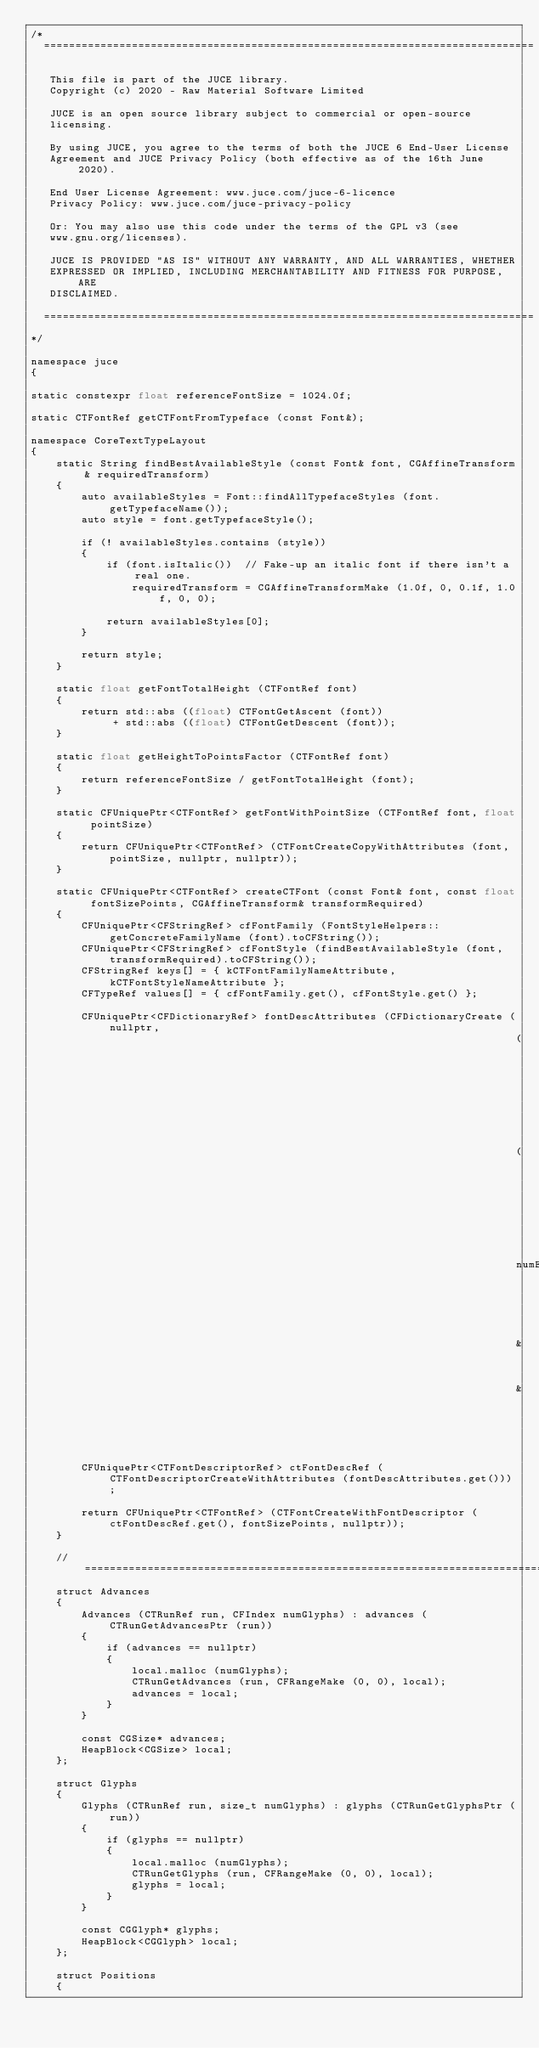<code> <loc_0><loc_0><loc_500><loc_500><_ObjectiveC_>/*
  ==============================================================================

   This file is part of the JUCE library.
   Copyright (c) 2020 - Raw Material Software Limited

   JUCE is an open source library subject to commercial or open-source
   licensing.

   By using JUCE, you agree to the terms of both the JUCE 6 End-User License
   Agreement and JUCE Privacy Policy (both effective as of the 16th June 2020).

   End User License Agreement: www.juce.com/juce-6-licence
   Privacy Policy: www.juce.com/juce-privacy-policy

   Or: You may also use this code under the terms of the GPL v3 (see
   www.gnu.org/licenses).

   JUCE IS PROVIDED "AS IS" WITHOUT ANY WARRANTY, AND ALL WARRANTIES, WHETHER
   EXPRESSED OR IMPLIED, INCLUDING MERCHANTABILITY AND FITNESS FOR PURPOSE, ARE
   DISCLAIMED.

  ==============================================================================
*/

namespace juce
{

static constexpr float referenceFontSize = 1024.0f;

static CTFontRef getCTFontFromTypeface (const Font&);

namespace CoreTextTypeLayout
{
    static String findBestAvailableStyle (const Font& font, CGAffineTransform& requiredTransform)
    {
        auto availableStyles = Font::findAllTypefaceStyles (font.getTypefaceName());
        auto style = font.getTypefaceStyle();

        if (! availableStyles.contains (style))
        {
            if (font.isItalic())  // Fake-up an italic font if there isn't a real one.
                requiredTransform = CGAffineTransformMake (1.0f, 0, 0.1f, 1.0f, 0, 0);

            return availableStyles[0];
        }

        return style;
    }

    static float getFontTotalHeight (CTFontRef font)
    {
        return std::abs ((float) CTFontGetAscent (font))
             + std::abs ((float) CTFontGetDescent (font));
    }

    static float getHeightToPointsFactor (CTFontRef font)
    {
        return referenceFontSize / getFontTotalHeight (font);
    }

    static CFUniquePtr<CTFontRef> getFontWithPointSize (CTFontRef font, float pointSize)
    {
        return CFUniquePtr<CTFontRef> (CTFontCreateCopyWithAttributes (font, pointSize, nullptr, nullptr));
    }

    static CFUniquePtr<CTFontRef> createCTFont (const Font& font, const float fontSizePoints, CGAffineTransform& transformRequired)
    {
        CFUniquePtr<CFStringRef> cfFontFamily (FontStyleHelpers::getConcreteFamilyName (font).toCFString());
        CFUniquePtr<CFStringRef> cfFontStyle (findBestAvailableStyle (font, transformRequired).toCFString());
        CFStringRef keys[] = { kCTFontFamilyNameAttribute, kCTFontStyleNameAttribute };
        CFTypeRef values[] = { cfFontFamily.get(), cfFontStyle.get() };

        CFUniquePtr<CFDictionaryRef> fontDescAttributes (CFDictionaryCreate (nullptr,
                                                                             (const void**) &keys,
                                                                             (const void**) &values,
                                                                             numElementsInArray (keys),
                                                                             &kCFTypeDictionaryKeyCallBacks,
                                                                             &kCFTypeDictionaryValueCallBacks));

        CFUniquePtr<CTFontDescriptorRef> ctFontDescRef (CTFontDescriptorCreateWithAttributes (fontDescAttributes.get()));

        return CFUniquePtr<CTFontRef> (CTFontCreateWithFontDescriptor (ctFontDescRef.get(), fontSizePoints, nullptr));
    }

    //==============================================================================
    struct Advances
    {
        Advances (CTRunRef run, CFIndex numGlyphs) : advances (CTRunGetAdvancesPtr (run))
        {
            if (advances == nullptr)
            {
                local.malloc (numGlyphs);
                CTRunGetAdvances (run, CFRangeMake (0, 0), local);
                advances = local;
            }
        }

        const CGSize* advances;
        HeapBlock<CGSize> local;
    };

    struct Glyphs
    {
        Glyphs (CTRunRef run, size_t numGlyphs) : glyphs (CTRunGetGlyphsPtr (run))
        {
            if (glyphs == nullptr)
            {
                local.malloc (numGlyphs);
                CTRunGetGlyphs (run, CFRangeMake (0, 0), local);
                glyphs = local;
            }
        }

        const CGGlyph* glyphs;
        HeapBlock<CGGlyph> local;
    };

    struct Positions
    {</code> 